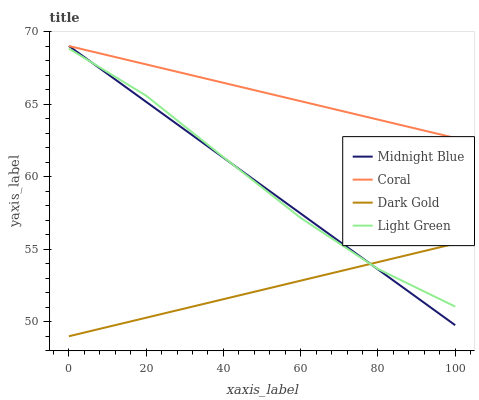Does Midnight Blue have the minimum area under the curve?
Answer yes or no. No. Does Midnight Blue have the maximum area under the curve?
Answer yes or no. No. Is Light Green the smoothest?
Answer yes or no. No. Is Midnight Blue the roughest?
Answer yes or no. No. Does Midnight Blue have the lowest value?
Answer yes or no. No. Does Light Green have the highest value?
Answer yes or no. No. Is Light Green less than Coral?
Answer yes or no. Yes. Is Coral greater than Light Green?
Answer yes or no. Yes. Does Light Green intersect Coral?
Answer yes or no. No. 